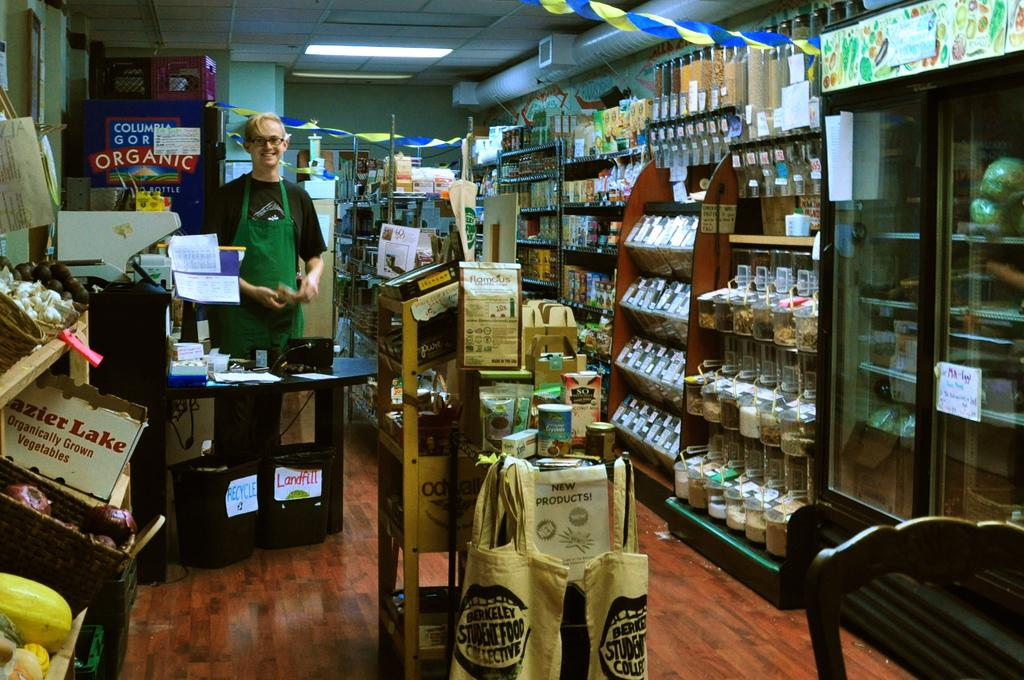<image>
Render a clear and concise summary of the photo. A store that sells some organically grown products. 